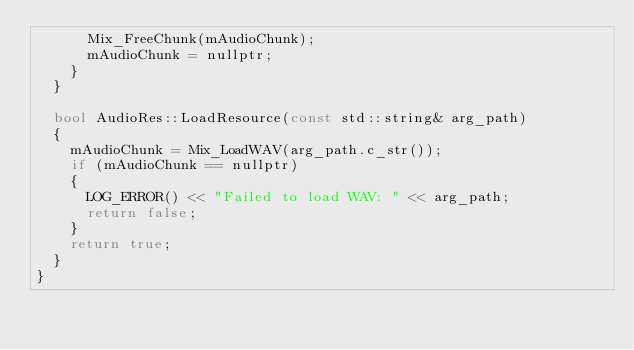Convert code to text. <code><loc_0><loc_0><loc_500><loc_500><_C++_>			Mix_FreeChunk(mAudioChunk);
			mAudioChunk = nullptr;
		}
	}

	bool AudioRes::LoadResource(const std::string& arg_path)
	{
		mAudioChunk = Mix_LoadWAV(arg_path.c_str());
		if (mAudioChunk == nullptr)
		{
			LOG_ERROR() << "Failed to load WAV: " << arg_path;
			return false;
		}
		return true;
	}
}
</code> 